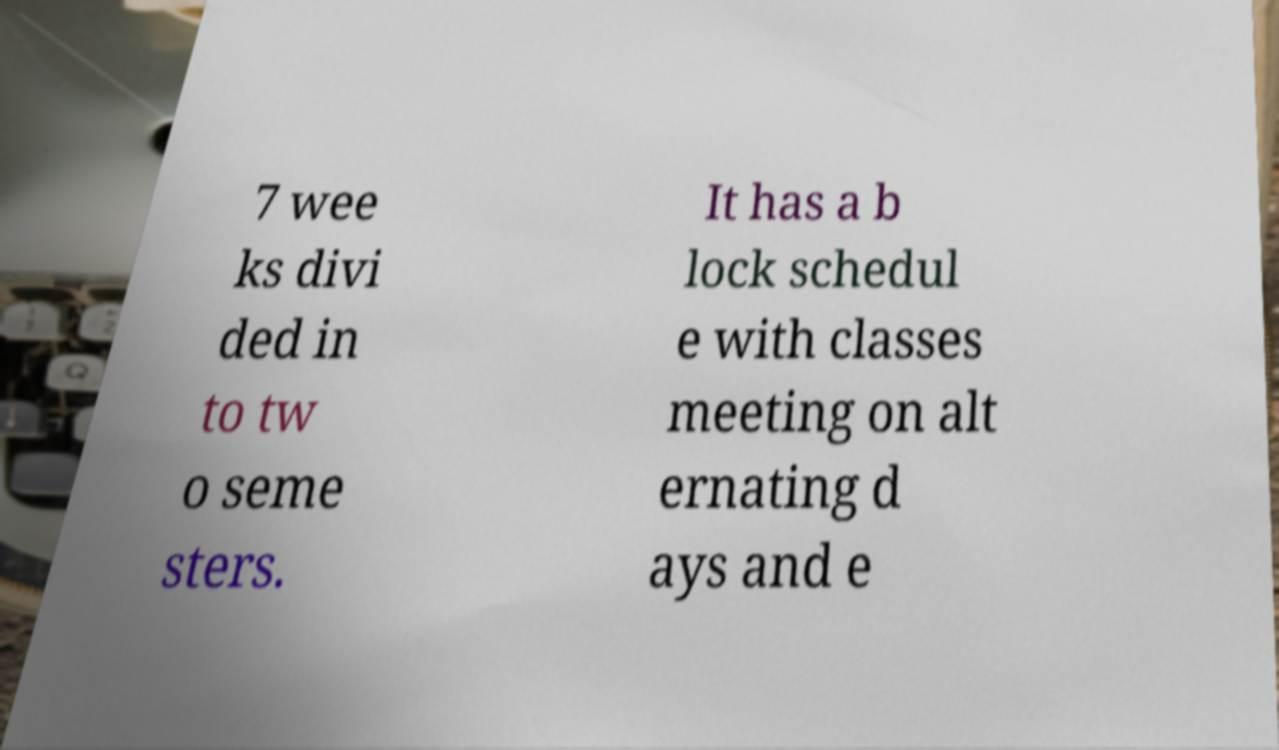I need the written content from this picture converted into text. Can you do that? 7 wee ks divi ded in to tw o seme sters. It has a b lock schedul e with classes meeting on alt ernating d ays and e 